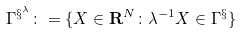<formula> <loc_0><loc_0><loc_500><loc_500>\Gamma ^ { \S ^ { \lambda } } \colon = \{ X \in { \mathbf R } ^ { N } \colon \lambda ^ { - 1 } X \in \Gamma ^ { \S } \} \,</formula> 